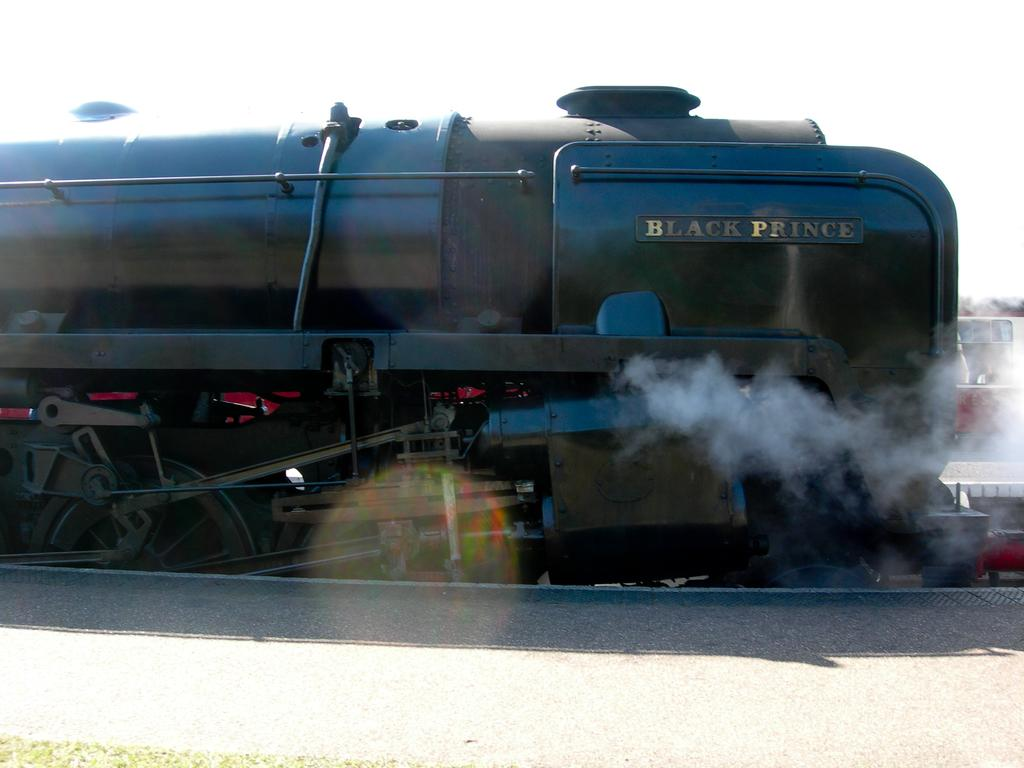What is the main structure in the image? There is a platform in the image. What is located on the platform? There is a train on the track in the image. What color is the train? The train is black in color. What can be seen coming from the train in the image? There is smoke visible in the image. What else can be seen in the background of the image? There is another train and the sky visible in the background of the image. Can you tell me how many tubs are in the image? There are no tubs present in the image. What type of show is being performed on the platform in the image? There is no show being performed on the platform in the image; it is a train station. 